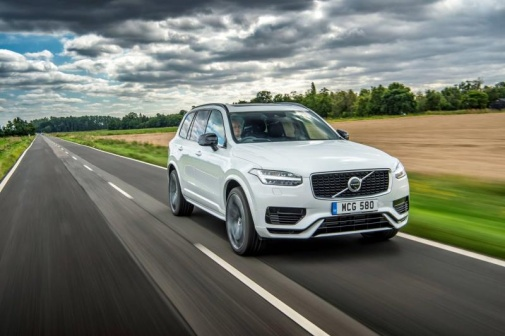What if this scene was part of a movie? Provide an imaginative storyline. In a film, this scene could be part of a dramatic storyline about a quest for self-discovery. The protagonist, Alex, has reached a crossroads in life and decides to take a journey through the countryside in their Volvo XC90. As Alex ventures onward after the rain, each mile on the wet road symbolizing the challenges overcome. Along the journey, Alex encounters remarkable characters and experiences that challenge their perspectives and force them to confront past regrets. Slowly, the endless highway transforms into a path of new beginnings, leading Alex to a hidden sanctuary that offers the peace and revelations needed to start anew, all set against the lush, vibrant backdrop just after a refreshing rain. 